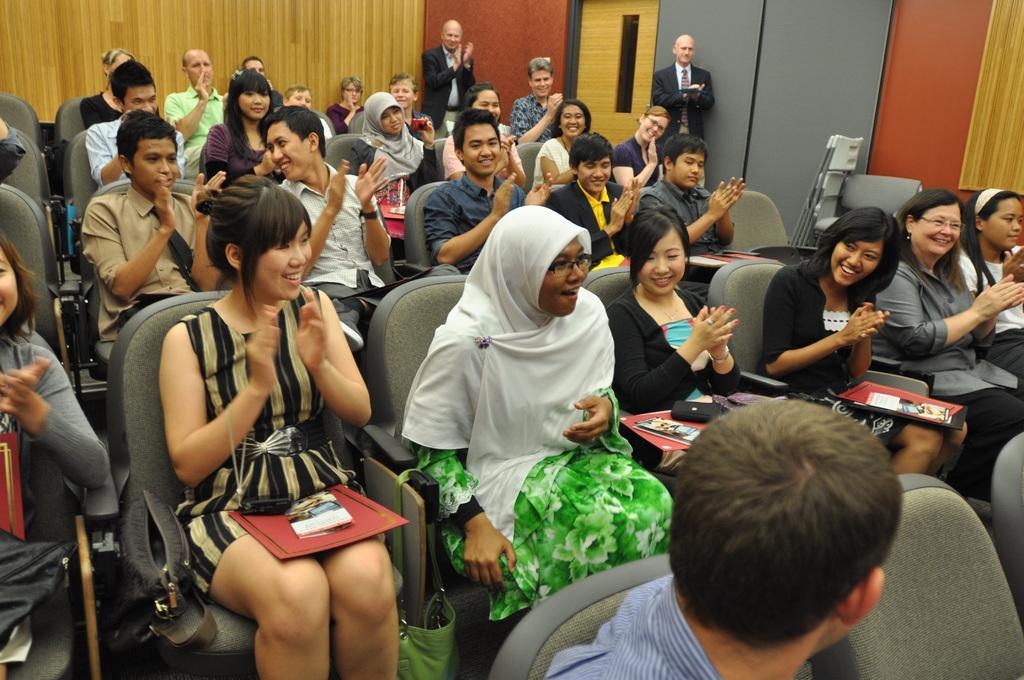Can you describe this image briefly? This picture is clicked inside the room. In the center we can see the group of persons sitting on the chairs and we can see some objects. In the background we can see the wall, door and two persons wearing suits and standing and we can see the chairs and some other objects. 